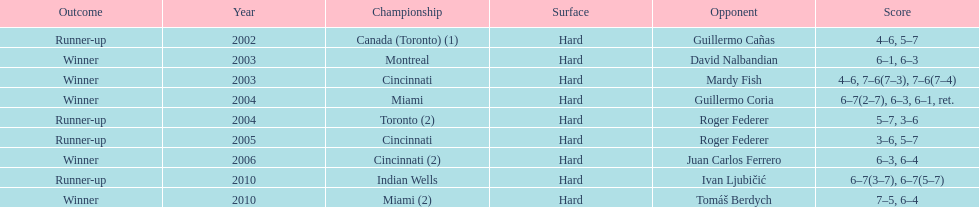Could you parse the entire table? {'header': ['Outcome', 'Year', 'Championship', 'Surface', 'Opponent', 'Score'], 'rows': [['Runner-up', '2002', 'Canada (Toronto) (1)', 'Hard', 'Guillermo Cañas', '4–6, 5–7'], ['Winner', '2003', 'Montreal', 'Hard', 'David Nalbandian', '6–1, 6–3'], ['Winner', '2003', 'Cincinnati', 'Hard', 'Mardy Fish', '4–6, 7–6(7–3), 7–6(7–4)'], ['Winner', '2004', 'Miami', 'Hard', 'Guillermo Coria', '6–7(2–7), 6–3, 6–1, ret.'], ['Runner-up', '2004', 'Toronto (2)', 'Hard', 'Roger Federer', '5–7, 3–6'], ['Runner-up', '2005', 'Cincinnati', 'Hard', 'Roger Federer', '3–6, 5–7'], ['Winner', '2006', 'Cincinnati (2)', 'Hard', 'Juan Carlos Ferrero', '6–3, 6–4'], ['Runner-up', '2010', 'Indian Wells', 'Hard', 'Ivan Ljubičić', '6–7(3–7), 6–7(5–7)'], ['Winner', '2010', 'Miami (2)', 'Hard', 'Tomáš Berdych', '7–5, 6–4']]} How many championships occurred in toronto or montreal? 3. 